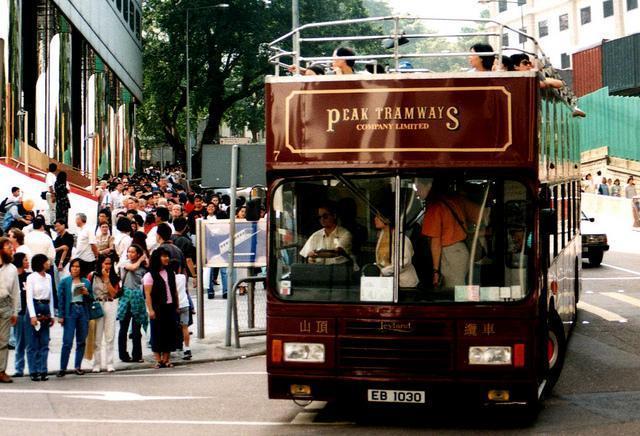How many people are there?
Give a very brief answer. 8. 